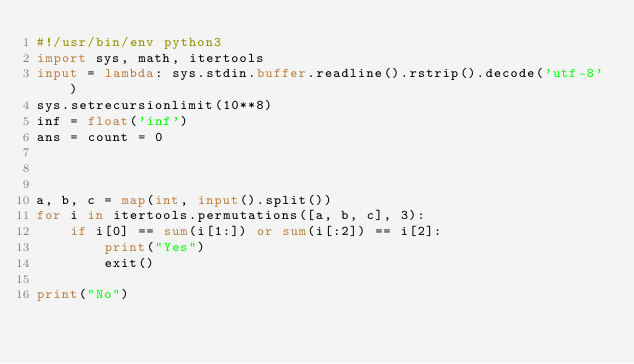<code> <loc_0><loc_0><loc_500><loc_500><_Python_>#!/usr/bin/env python3
import sys, math, itertools
input = lambda: sys.stdin.buffer.readline().rstrip().decode('utf-8')
sys.setrecursionlimit(10**8)
inf = float('inf')
ans = count = 0



a, b, c = map(int, input().split())
for i in itertools.permutations([a, b, c], 3):
    if i[0] == sum(i[1:]) or sum(i[:2]) == i[2]:
        print("Yes")
        exit()

print("No")
</code> 